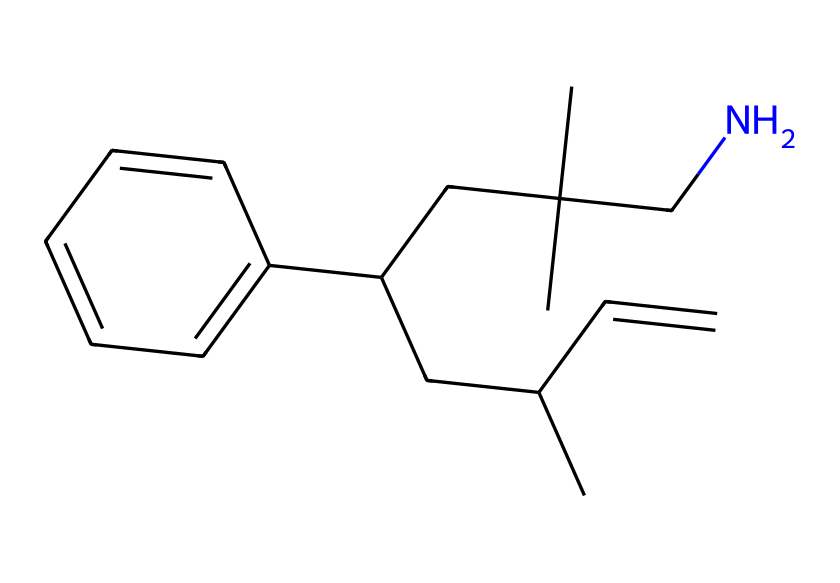How many carbon atoms are in this structure? By analyzing the SMILES representation, we can count the number of carbon (C) atoms represented. Each "C" stands for a carbon atom, and we can sum them up in the provided structure.
Answer: twelve What type of polymer is represented here? The structure indicates a polymer characterized by repeating units of carbon chains, with functional groups suggesting it's a thermoplastic, widely used in toy building blocks.
Answer: thermoplastic How many distinct rings are present in the structure? The chemical representation does not show any cyclical structures, as there are no closed paths indicated in the SMILES string. This confirms that there are no rings.
Answer: zero Is there a nitrogen atom in this structure? Observing the SMILES representation, we can see the presence of a "N" which confirms the presence of a nitrogen atom within the structure.
Answer: yes Which part of this chemical contributes to its flexibility? The long carbon chain structure with various branching (CC and CCC groups) contributes to flexibility by allowing movement between the polymer chains, preventing rigidity.
Answer: branching How many functional groups can be identified in this polymer? By analyzing the structure, we can identify that the main functional group in this polymer is the amine group (-CN) that influences its properties.
Answer: one What property does the presence of nitrogen suggest in this polymer? The presence of nitrogen typically suggests that the polymer can exhibit properties like improved tensile strength and elasticity due to potential interactions within the polymer matrix.
Answer: improved strength 